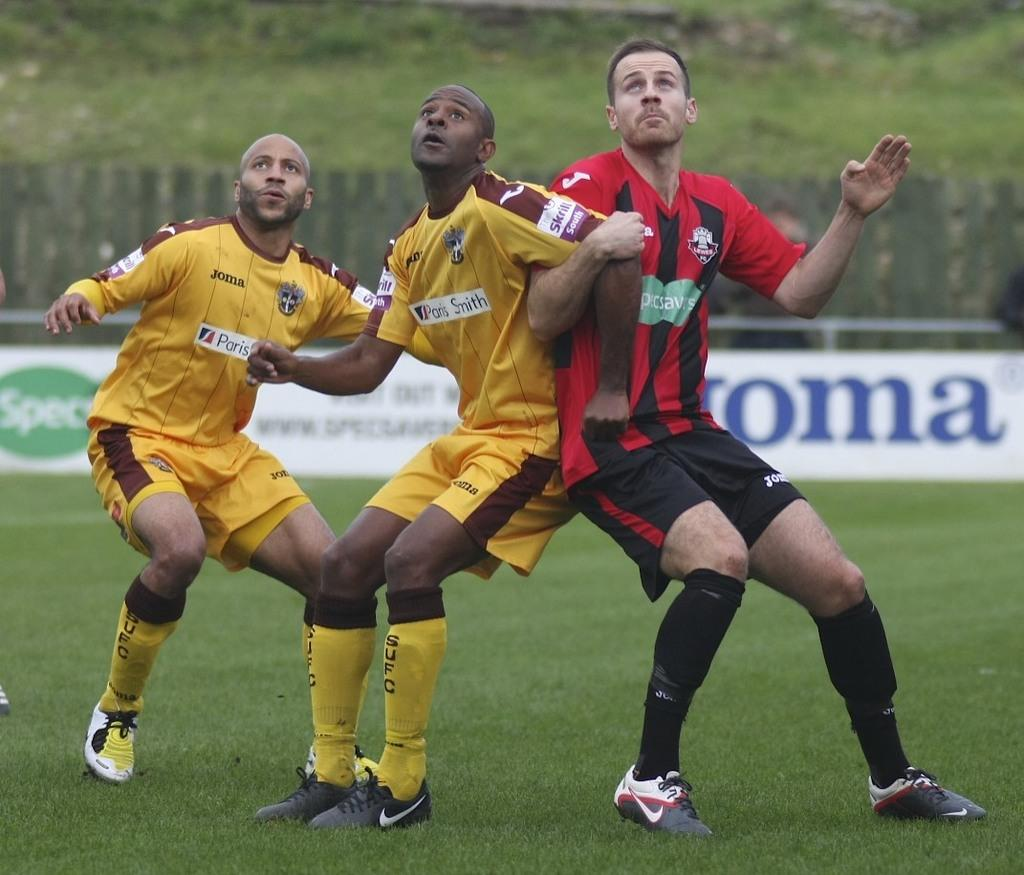Provide a one-sentence caption for the provided image. One football team is sponsored by specsavers, the other by Paris Smith. 